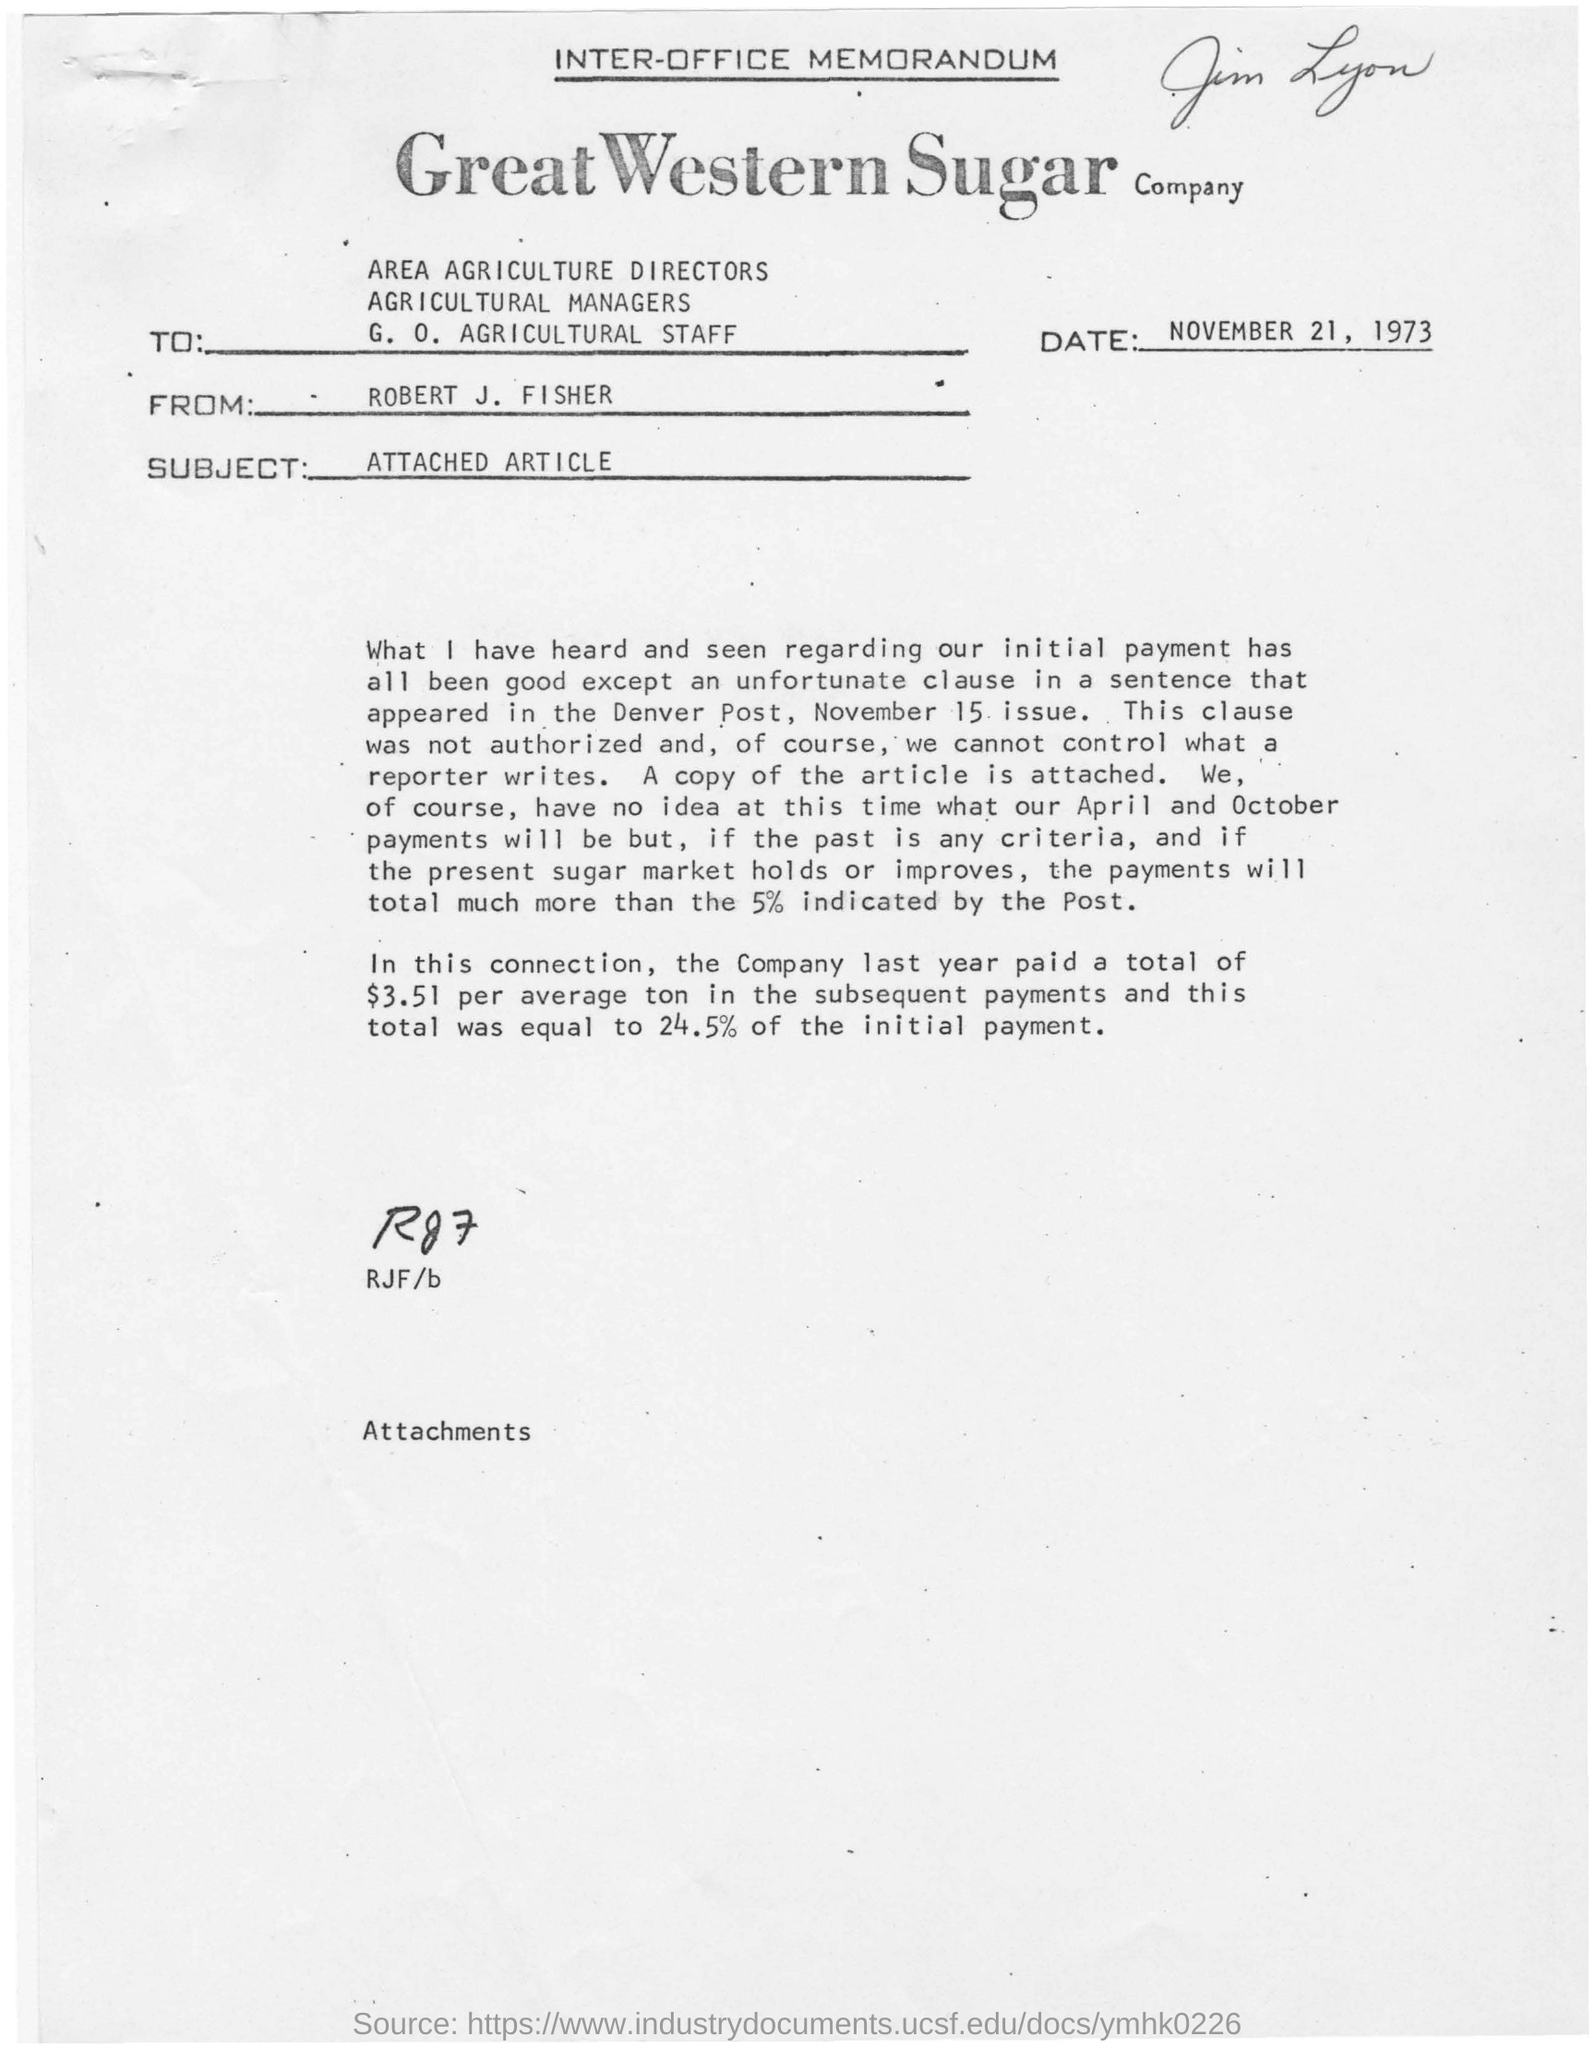Who's name is written with pencil at the top of the document?
Make the answer very short. JIM LYON. When is the memorandum dated on?
Offer a terse response. NOVEMBER 21, 1973. Who wrote this memorandum ?
Give a very brief answer. Robert J. fisher. What is subject for this inter-office memorandum?
Provide a short and direct response. Attached article. How much amount of money paid last year by the great western sugar company in the subsequent payments?
Your response must be concise. A total of $3.51 per average ton. What is the name of sugar company?
Your response must be concise. GREAT WESTERN SUGAR COMPANY. What is mentioned above of rjf/b?
Give a very brief answer. RG7. 